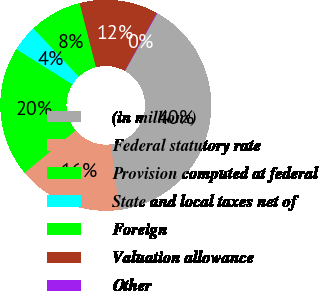Convert chart. <chart><loc_0><loc_0><loc_500><loc_500><pie_chart><fcel>(in millions)<fcel>Federal statutory rate<fcel>Provision computed at federal<fcel>State and local taxes net of<fcel>Foreign<fcel>Valuation allowance<fcel>Other<nl><fcel>39.86%<fcel>15.99%<fcel>19.97%<fcel>4.06%<fcel>8.03%<fcel>12.01%<fcel>0.08%<nl></chart> 